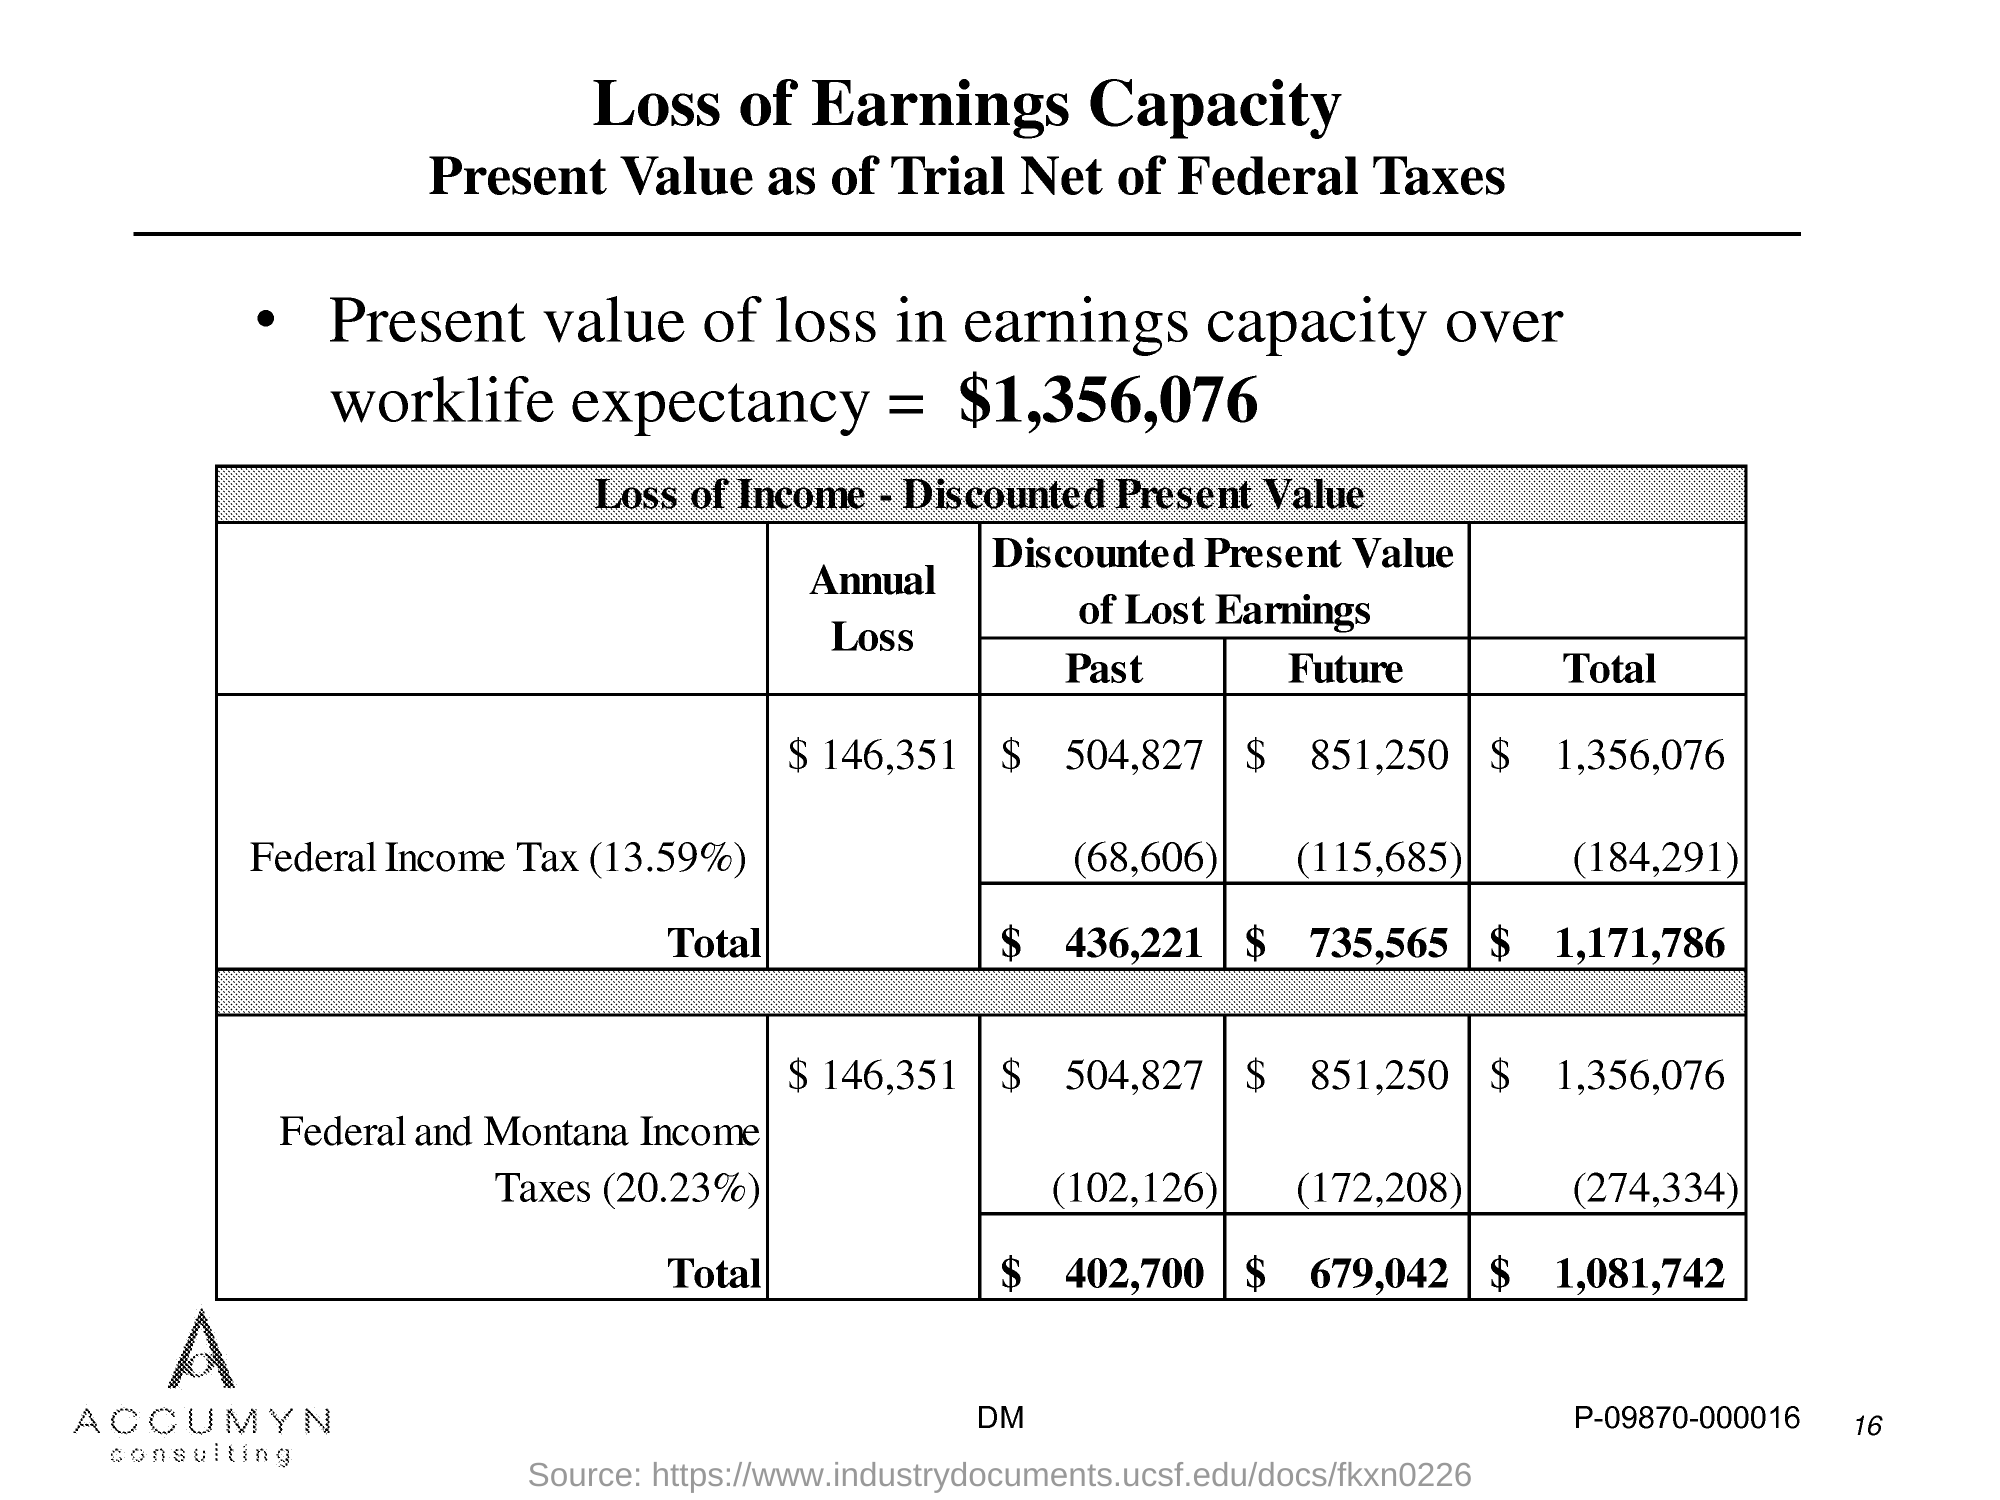What is the present value of loss in earnings capacity over worklife expectancy?
Give a very brief answer. 1,356,076. 